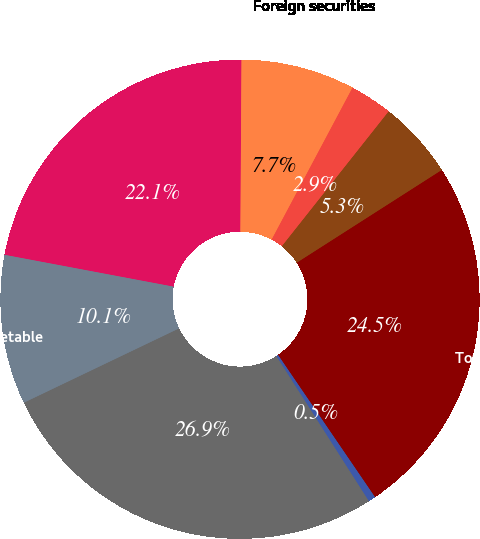Convert chart to OTSL. <chart><loc_0><loc_0><loc_500><loc_500><pie_chart><fcel>Mortgage-backed securities (1)<fcel>Foreign securities<fcel>Corporate/Agency bonds<fcel>Other taxable securities (2)<fcel>Total taxable securities<fcel>Tax-exempt securities<fcel>Total available-for-sale debt<fcel>Available-for-sale marketable<nl><fcel>22.14%<fcel>7.68%<fcel>2.88%<fcel>5.28%<fcel>24.53%<fcel>0.49%<fcel>26.93%<fcel>10.07%<nl></chart> 